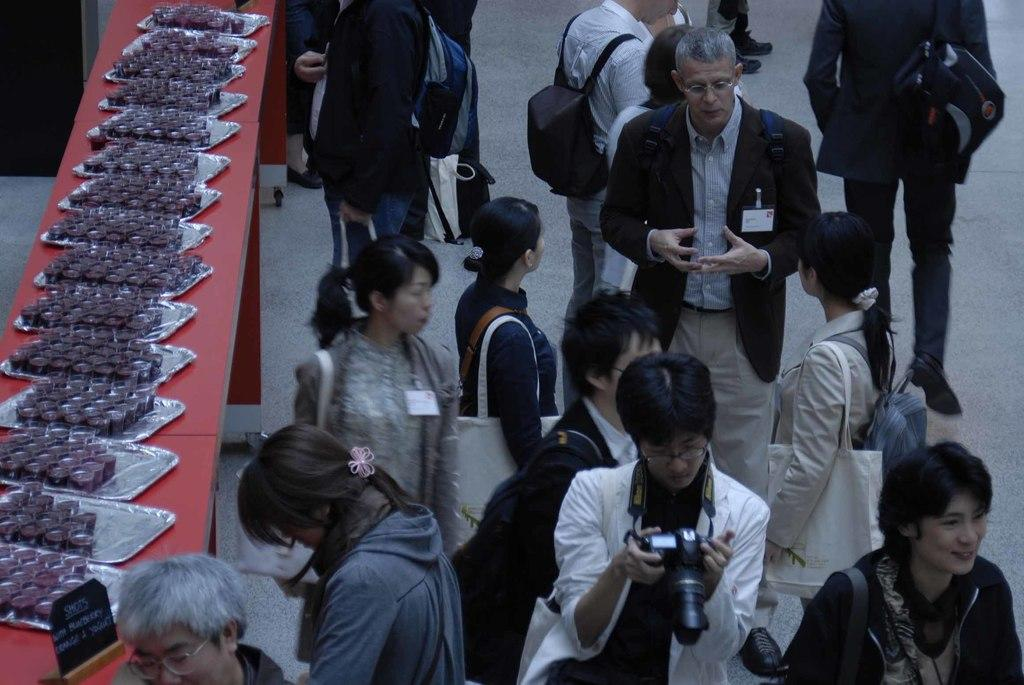What is the main activity happening in the image? There are many people standing in one place in the image. Can you describe the arrangement of plates in the image? There is a slope with plates arranged on it in the image. What is the condition of the zoo in the image? There is no zoo present in the image; it features a gathering of people and a slope with plates arranged on it. 